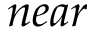Convert formula to latex. <formula><loc_0><loc_0><loc_500><loc_500>n e a r</formula> 